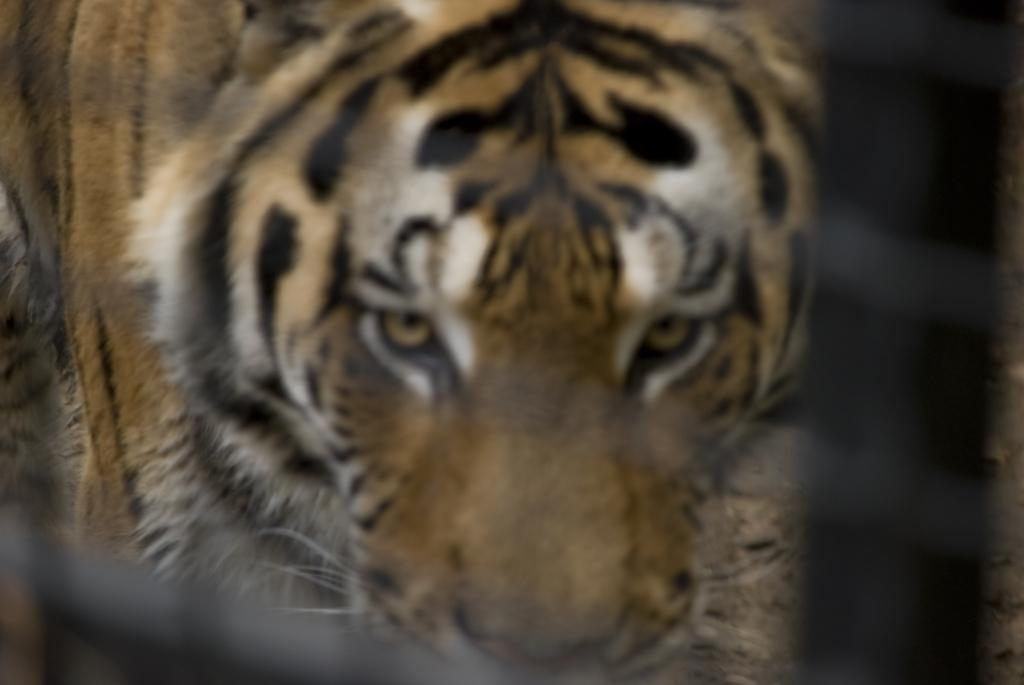What type of animal is in the image? There is a tiger in the image. What type of lettuce is being used as a decoration at the event in the image? There is no lettuce or event present in the image; it features a tiger. How does the tiger blow out the candles on the cake in the image? There is no cake or candles present in the image; it features a tiger. 